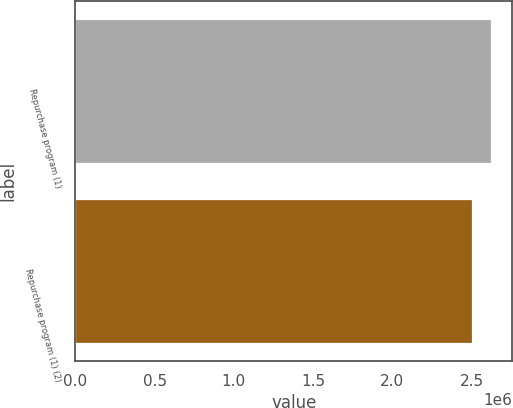<chart> <loc_0><loc_0><loc_500><loc_500><bar_chart><fcel>Repurchase program (1)<fcel>Repurchase program (1) (2)<nl><fcel>2.6248e+06<fcel>2.50407e+06<nl></chart> 